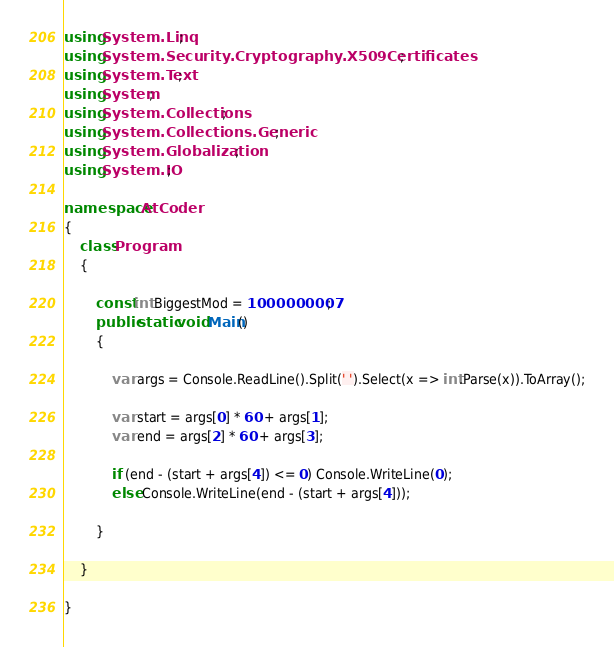<code> <loc_0><loc_0><loc_500><loc_500><_C#_>using System.Linq;
using System.Security.Cryptography.X509Certificates;
using System.Text;
using System;
using System.Collections;
using System.Collections.Generic;
using System.Globalization;
using System.IO;

namespace AtCoder
{
    class Program
    {

        const int BiggestMod = 1000000007;
        public static void Main()
        {

            var args = Console.ReadLine().Split(' ').Select(x => int.Parse(x)).ToArray();

            var start = args[0] * 60 + args[1];
            var end = args[2] * 60 + args[3];

            if (end - (start + args[4]) <= 0) Console.WriteLine(0);
            else Console.WriteLine(end - (start + args[4]));

        }

    }

}</code> 